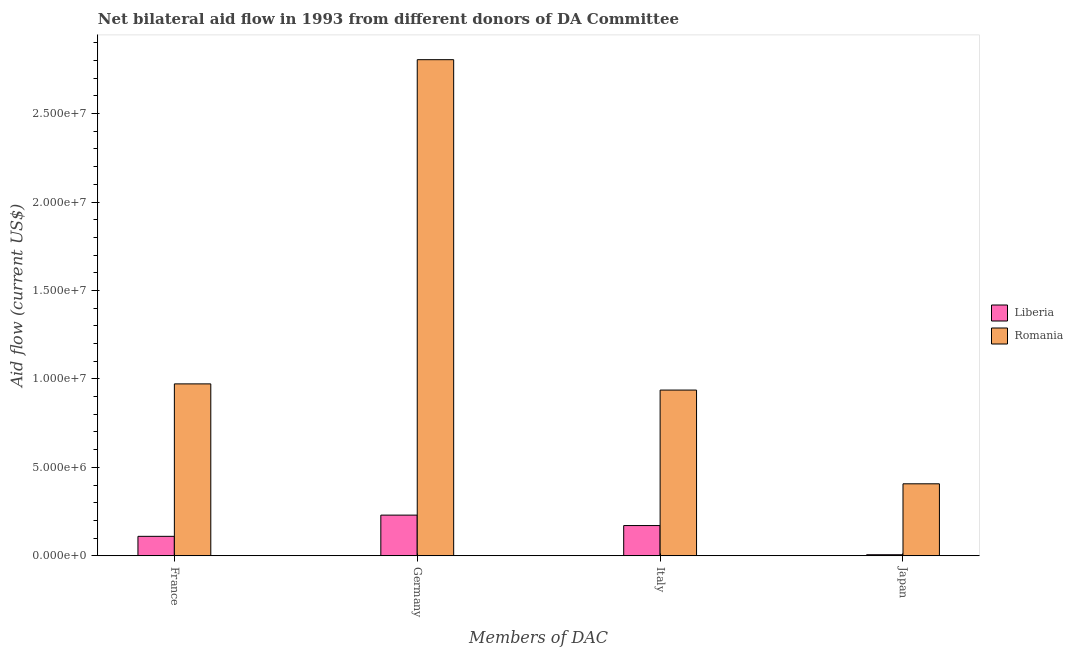How many different coloured bars are there?
Ensure brevity in your answer.  2. Are the number of bars per tick equal to the number of legend labels?
Keep it short and to the point. Yes. How many bars are there on the 1st tick from the left?
Your answer should be very brief. 2. What is the amount of aid given by germany in Romania?
Offer a very short reply. 2.80e+07. Across all countries, what is the maximum amount of aid given by germany?
Your answer should be very brief. 2.80e+07. Across all countries, what is the minimum amount of aid given by france?
Your response must be concise. 1.10e+06. In which country was the amount of aid given by germany maximum?
Your response must be concise. Romania. In which country was the amount of aid given by germany minimum?
Make the answer very short. Liberia. What is the total amount of aid given by france in the graph?
Provide a succinct answer. 1.08e+07. What is the difference between the amount of aid given by france in Liberia and that in Romania?
Your response must be concise. -8.62e+06. What is the difference between the amount of aid given by japan in Romania and the amount of aid given by italy in Liberia?
Keep it short and to the point. 2.36e+06. What is the average amount of aid given by italy per country?
Make the answer very short. 5.54e+06. What is the difference between the amount of aid given by italy and amount of aid given by japan in Liberia?
Provide a short and direct response. 1.65e+06. In how many countries, is the amount of aid given by italy greater than 17000000 US$?
Provide a short and direct response. 0. What is the ratio of the amount of aid given by italy in Liberia to that in Romania?
Your response must be concise. 0.18. Is the difference between the amount of aid given by france in Romania and Liberia greater than the difference between the amount of aid given by japan in Romania and Liberia?
Ensure brevity in your answer.  Yes. What is the difference between the highest and the second highest amount of aid given by italy?
Make the answer very short. 7.66e+06. What is the difference between the highest and the lowest amount of aid given by germany?
Offer a very short reply. 2.58e+07. In how many countries, is the amount of aid given by japan greater than the average amount of aid given by japan taken over all countries?
Offer a very short reply. 1. What does the 2nd bar from the left in Germany represents?
Keep it short and to the point. Romania. What does the 1st bar from the right in Italy represents?
Offer a terse response. Romania. How many countries are there in the graph?
Provide a succinct answer. 2. What is the difference between two consecutive major ticks on the Y-axis?
Keep it short and to the point. 5.00e+06. Are the values on the major ticks of Y-axis written in scientific E-notation?
Keep it short and to the point. Yes. Does the graph contain any zero values?
Your answer should be very brief. No. How many legend labels are there?
Provide a succinct answer. 2. What is the title of the graph?
Offer a terse response. Net bilateral aid flow in 1993 from different donors of DA Committee. What is the label or title of the X-axis?
Offer a very short reply. Members of DAC. What is the Aid flow (current US$) in Liberia in France?
Your answer should be very brief. 1.10e+06. What is the Aid flow (current US$) in Romania in France?
Ensure brevity in your answer.  9.72e+06. What is the Aid flow (current US$) in Liberia in Germany?
Make the answer very short. 2.30e+06. What is the Aid flow (current US$) of Romania in Germany?
Ensure brevity in your answer.  2.80e+07. What is the Aid flow (current US$) in Liberia in Italy?
Your answer should be compact. 1.71e+06. What is the Aid flow (current US$) in Romania in Italy?
Offer a very short reply. 9.37e+06. What is the Aid flow (current US$) in Liberia in Japan?
Make the answer very short. 6.00e+04. What is the Aid flow (current US$) in Romania in Japan?
Ensure brevity in your answer.  4.07e+06. Across all Members of DAC, what is the maximum Aid flow (current US$) of Liberia?
Provide a succinct answer. 2.30e+06. Across all Members of DAC, what is the maximum Aid flow (current US$) of Romania?
Keep it short and to the point. 2.80e+07. Across all Members of DAC, what is the minimum Aid flow (current US$) of Romania?
Your answer should be compact. 4.07e+06. What is the total Aid flow (current US$) of Liberia in the graph?
Give a very brief answer. 5.17e+06. What is the total Aid flow (current US$) in Romania in the graph?
Make the answer very short. 5.12e+07. What is the difference between the Aid flow (current US$) in Liberia in France and that in Germany?
Your answer should be very brief. -1.20e+06. What is the difference between the Aid flow (current US$) in Romania in France and that in Germany?
Give a very brief answer. -1.83e+07. What is the difference between the Aid flow (current US$) of Liberia in France and that in Italy?
Your answer should be compact. -6.10e+05. What is the difference between the Aid flow (current US$) in Romania in France and that in Italy?
Your response must be concise. 3.50e+05. What is the difference between the Aid flow (current US$) of Liberia in France and that in Japan?
Offer a very short reply. 1.04e+06. What is the difference between the Aid flow (current US$) in Romania in France and that in Japan?
Your answer should be very brief. 5.65e+06. What is the difference between the Aid flow (current US$) in Liberia in Germany and that in Italy?
Your answer should be compact. 5.90e+05. What is the difference between the Aid flow (current US$) of Romania in Germany and that in Italy?
Keep it short and to the point. 1.87e+07. What is the difference between the Aid flow (current US$) of Liberia in Germany and that in Japan?
Your response must be concise. 2.24e+06. What is the difference between the Aid flow (current US$) in Romania in Germany and that in Japan?
Your answer should be very brief. 2.40e+07. What is the difference between the Aid flow (current US$) in Liberia in Italy and that in Japan?
Your response must be concise. 1.65e+06. What is the difference between the Aid flow (current US$) in Romania in Italy and that in Japan?
Keep it short and to the point. 5.30e+06. What is the difference between the Aid flow (current US$) in Liberia in France and the Aid flow (current US$) in Romania in Germany?
Ensure brevity in your answer.  -2.70e+07. What is the difference between the Aid flow (current US$) in Liberia in France and the Aid flow (current US$) in Romania in Italy?
Offer a terse response. -8.27e+06. What is the difference between the Aid flow (current US$) in Liberia in France and the Aid flow (current US$) in Romania in Japan?
Your answer should be compact. -2.97e+06. What is the difference between the Aid flow (current US$) of Liberia in Germany and the Aid flow (current US$) of Romania in Italy?
Your answer should be very brief. -7.07e+06. What is the difference between the Aid flow (current US$) in Liberia in Germany and the Aid flow (current US$) in Romania in Japan?
Offer a very short reply. -1.77e+06. What is the difference between the Aid flow (current US$) in Liberia in Italy and the Aid flow (current US$) in Romania in Japan?
Your response must be concise. -2.36e+06. What is the average Aid flow (current US$) in Liberia per Members of DAC?
Give a very brief answer. 1.29e+06. What is the average Aid flow (current US$) in Romania per Members of DAC?
Provide a succinct answer. 1.28e+07. What is the difference between the Aid flow (current US$) of Liberia and Aid flow (current US$) of Romania in France?
Provide a short and direct response. -8.62e+06. What is the difference between the Aid flow (current US$) in Liberia and Aid flow (current US$) in Romania in Germany?
Your response must be concise. -2.58e+07. What is the difference between the Aid flow (current US$) of Liberia and Aid flow (current US$) of Romania in Italy?
Keep it short and to the point. -7.66e+06. What is the difference between the Aid flow (current US$) in Liberia and Aid flow (current US$) in Romania in Japan?
Make the answer very short. -4.01e+06. What is the ratio of the Aid flow (current US$) of Liberia in France to that in Germany?
Provide a short and direct response. 0.48. What is the ratio of the Aid flow (current US$) of Romania in France to that in Germany?
Keep it short and to the point. 0.35. What is the ratio of the Aid flow (current US$) of Liberia in France to that in Italy?
Give a very brief answer. 0.64. What is the ratio of the Aid flow (current US$) in Romania in France to that in Italy?
Give a very brief answer. 1.04. What is the ratio of the Aid flow (current US$) in Liberia in France to that in Japan?
Your answer should be very brief. 18.33. What is the ratio of the Aid flow (current US$) in Romania in France to that in Japan?
Your answer should be compact. 2.39. What is the ratio of the Aid flow (current US$) in Liberia in Germany to that in Italy?
Offer a very short reply. 1.34. What is the ratio of the Aid flow (current US$) of Romania in Germany to that in Italy?
Your response must be concise. 2.99. What is the ratio of the Aid flow (current US$) of Liberia in Germany to that in Japan?
Ensure brevity in your answer.  38.33. What is the ratio of the Aid flow (current US$) in Romania in Germany to that in Japan?
Provide a short and direct response. 6.89. What is the ratio of the Aid flow (current US$) of Liberia in Italy to that in Japan?
Provide a succinct answer. 28.5. What is the ratio of the Aid flow (current US$) in Romania in Italy to that in Japan?
Your response must be concise. 2.3. What is the difference between the highest and the second highest Aid flow (current US$) of Liberia?
Your response must be concise. 5.90e+05. What is the difference between the highest and the second highest Aid flow (current US$) of Romania?
Your response must be concise. 1.83e+07. What is the difference between the highest and the lowest Aid flow (current US$) of Liberia?
Offer a very short reply. 2.24e+06. What is the difference between the highest and the lowest Aid flow (current US$) of Romania?
Keep it short and to the point. 2.40e+07. 